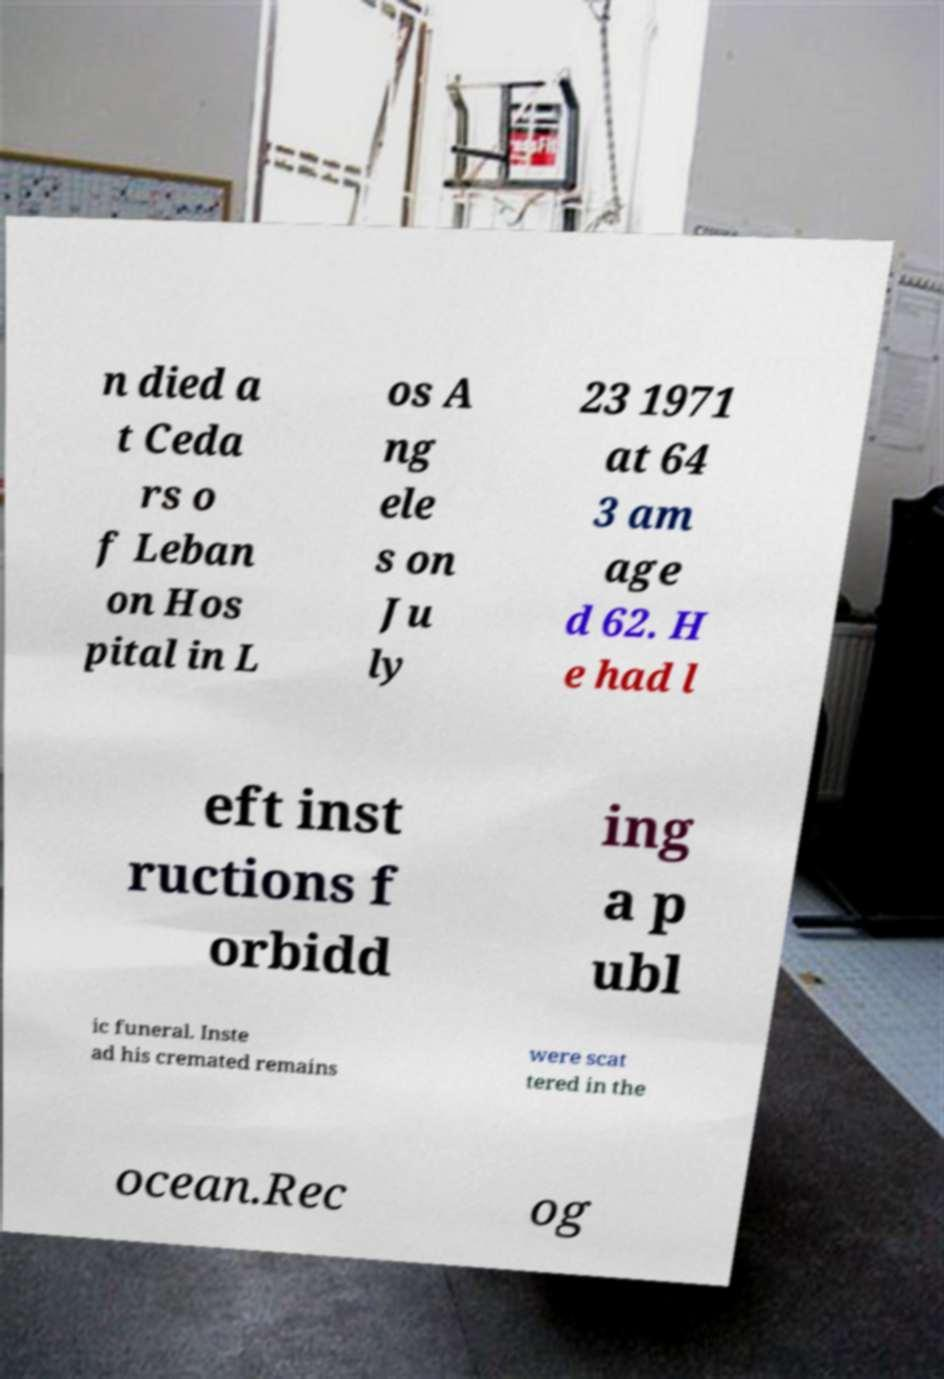I need the written content from this picture converted into text. Can you do that? n died a t Ceda rs o f Leban on Hos pital in L os A ng ele s on Ju ly 23 1971 at 64 3 am age d 62. H e had l eft inst ructions f orbidd ing a p ubl ic funeral. Inste ad his cremated remains were scat tered in the ocean.Rec og 